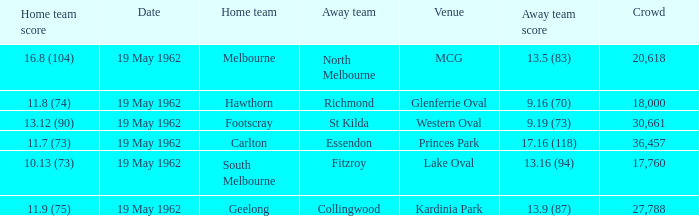What is the away team's score when the home team scores 16.8 (104)? 13.5 (83). 